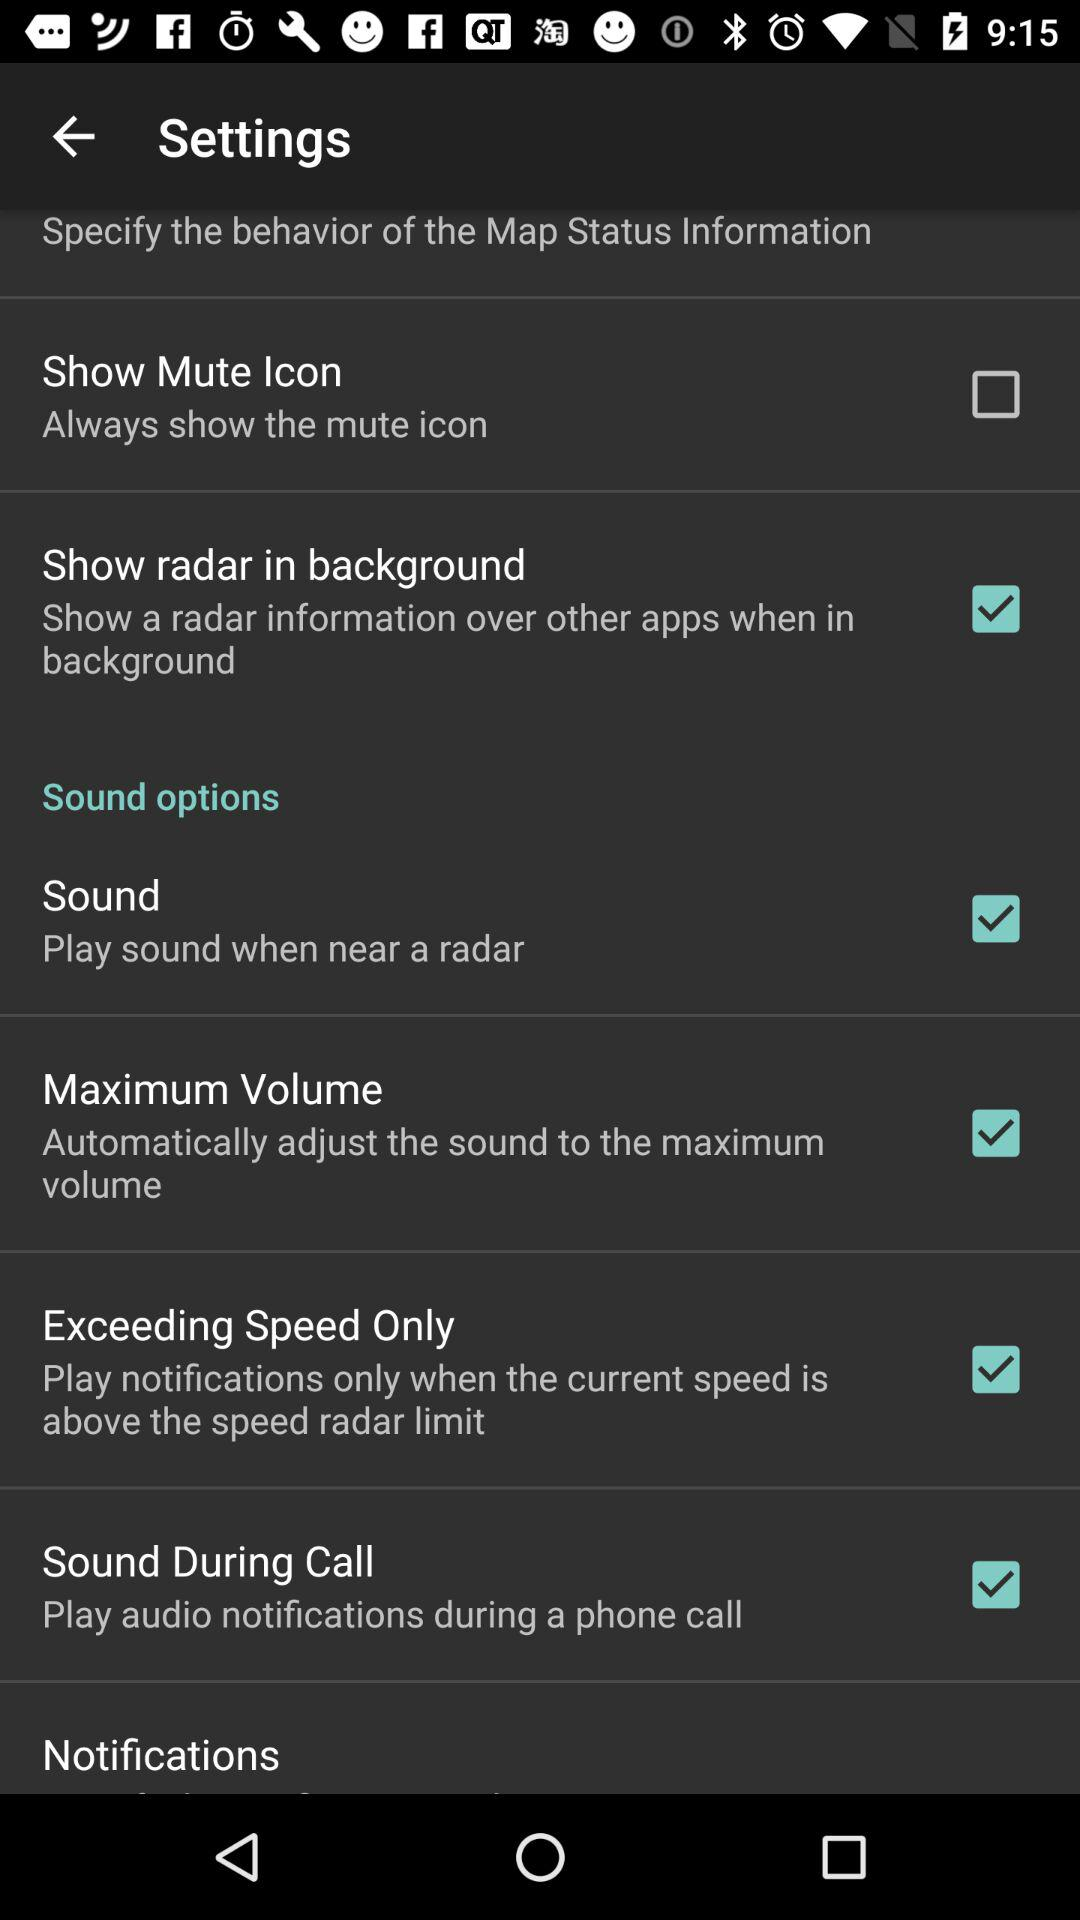When will the sound play? The sound will play near a radar. 